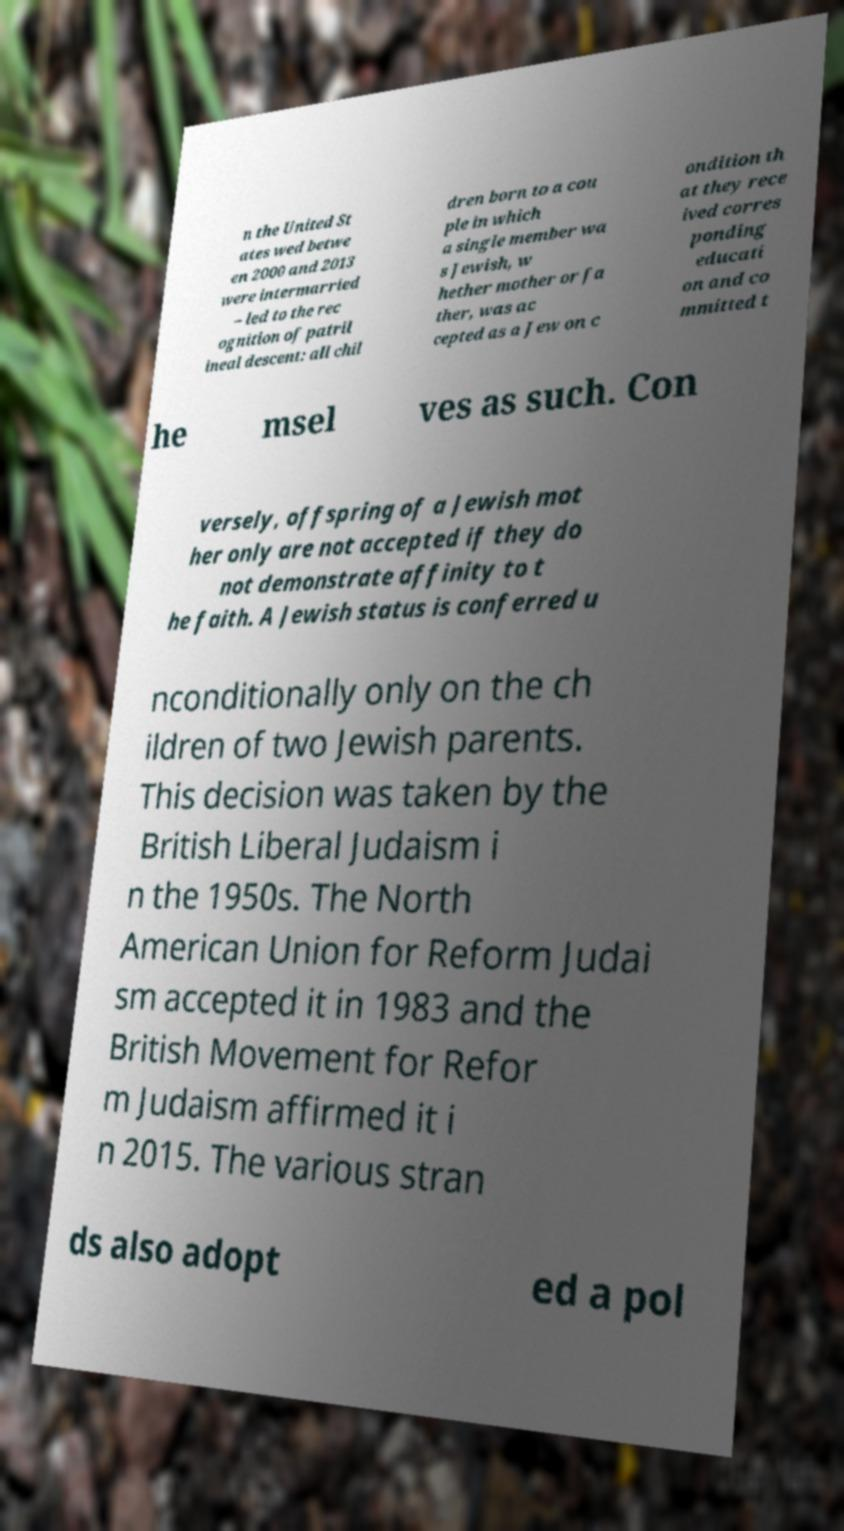What messages or text are displayed in this image? I need them in a readable, typed format. n the United St ates wed betwe en 2000 and 2013 were intermarried – led to the rec ognition of patril ineal descent: all chil dren born to a cou ple in which a single member wa s Jewish, w hether mother or fa ther, was ac cepted as a Jew on c ondition th at they rece ived corres ponding educati on and co mmitted t he msel ves as such. Con versely, offspring of a Jewish mot her only are not accepted if they do not demonstrate affinity to t he faith. A Jewish status is conferred u nconditionally only on the ch ildren of two Jewish parents. This decision was taken by the British Liberal Judaism i n the 1950s. The North American Union for Reform Judai sm accepted it in 1983 and the British Movement for Refor m Judaism affirmed it i n 2015. The various stran ds also adopt ed a pol 